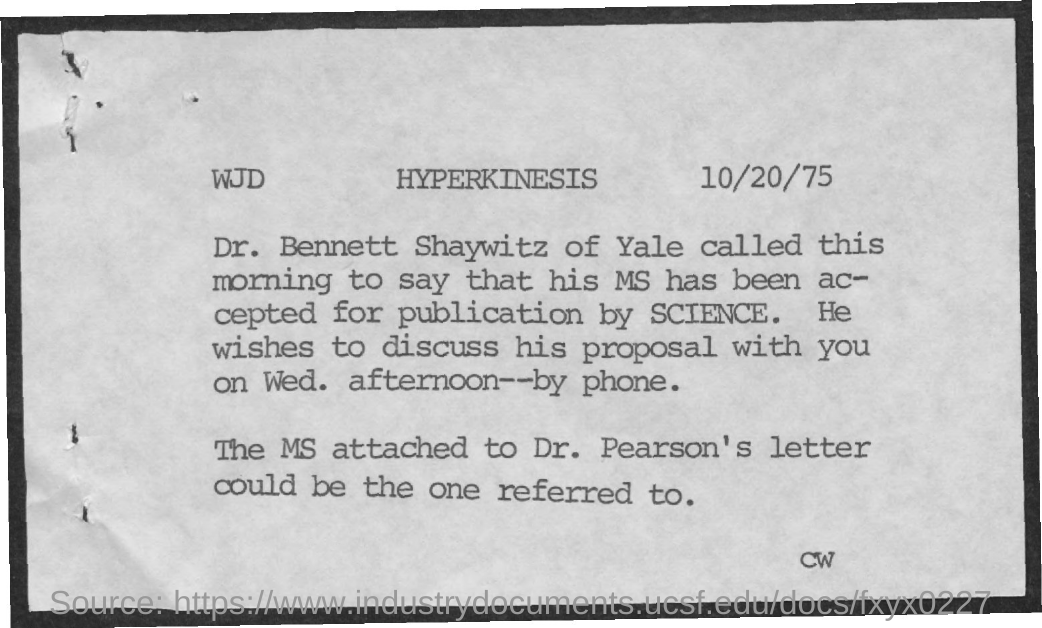Outline some significant characteristics in this image. The title of the document is "Hyperkinesis. The date on the document is October 20, 1975. 